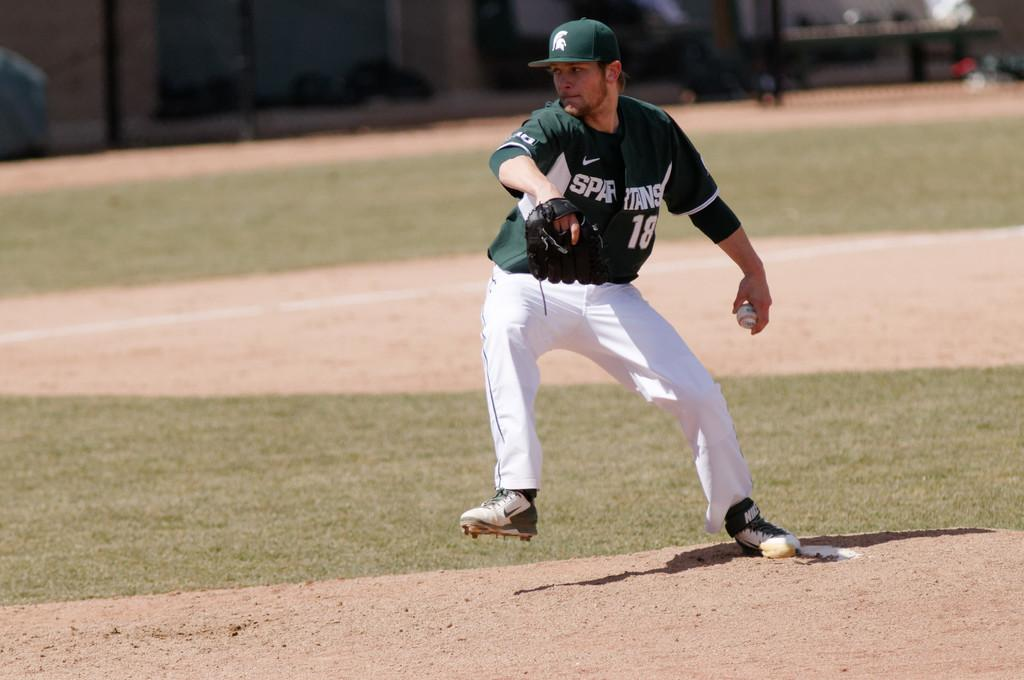Provide a one-sentence caption for the provided image. a man wearing a green spartans jersey on the mound. 